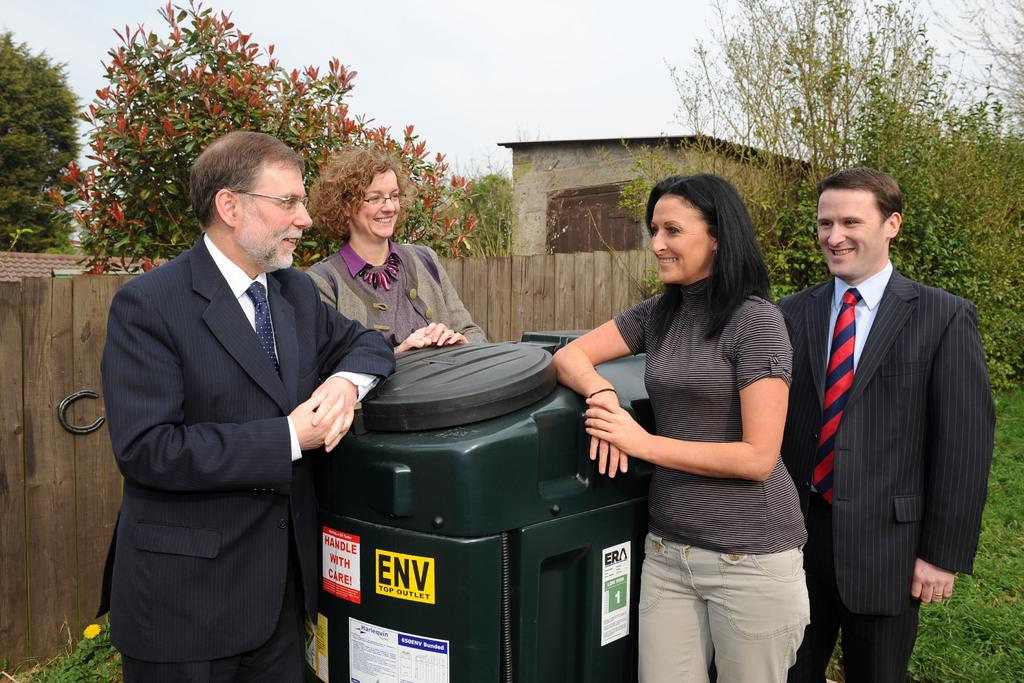<image>
Share a concise interpretation of the image provided. Four dressed-up people around a garbage can that reads HANDLE WITH CARE. 